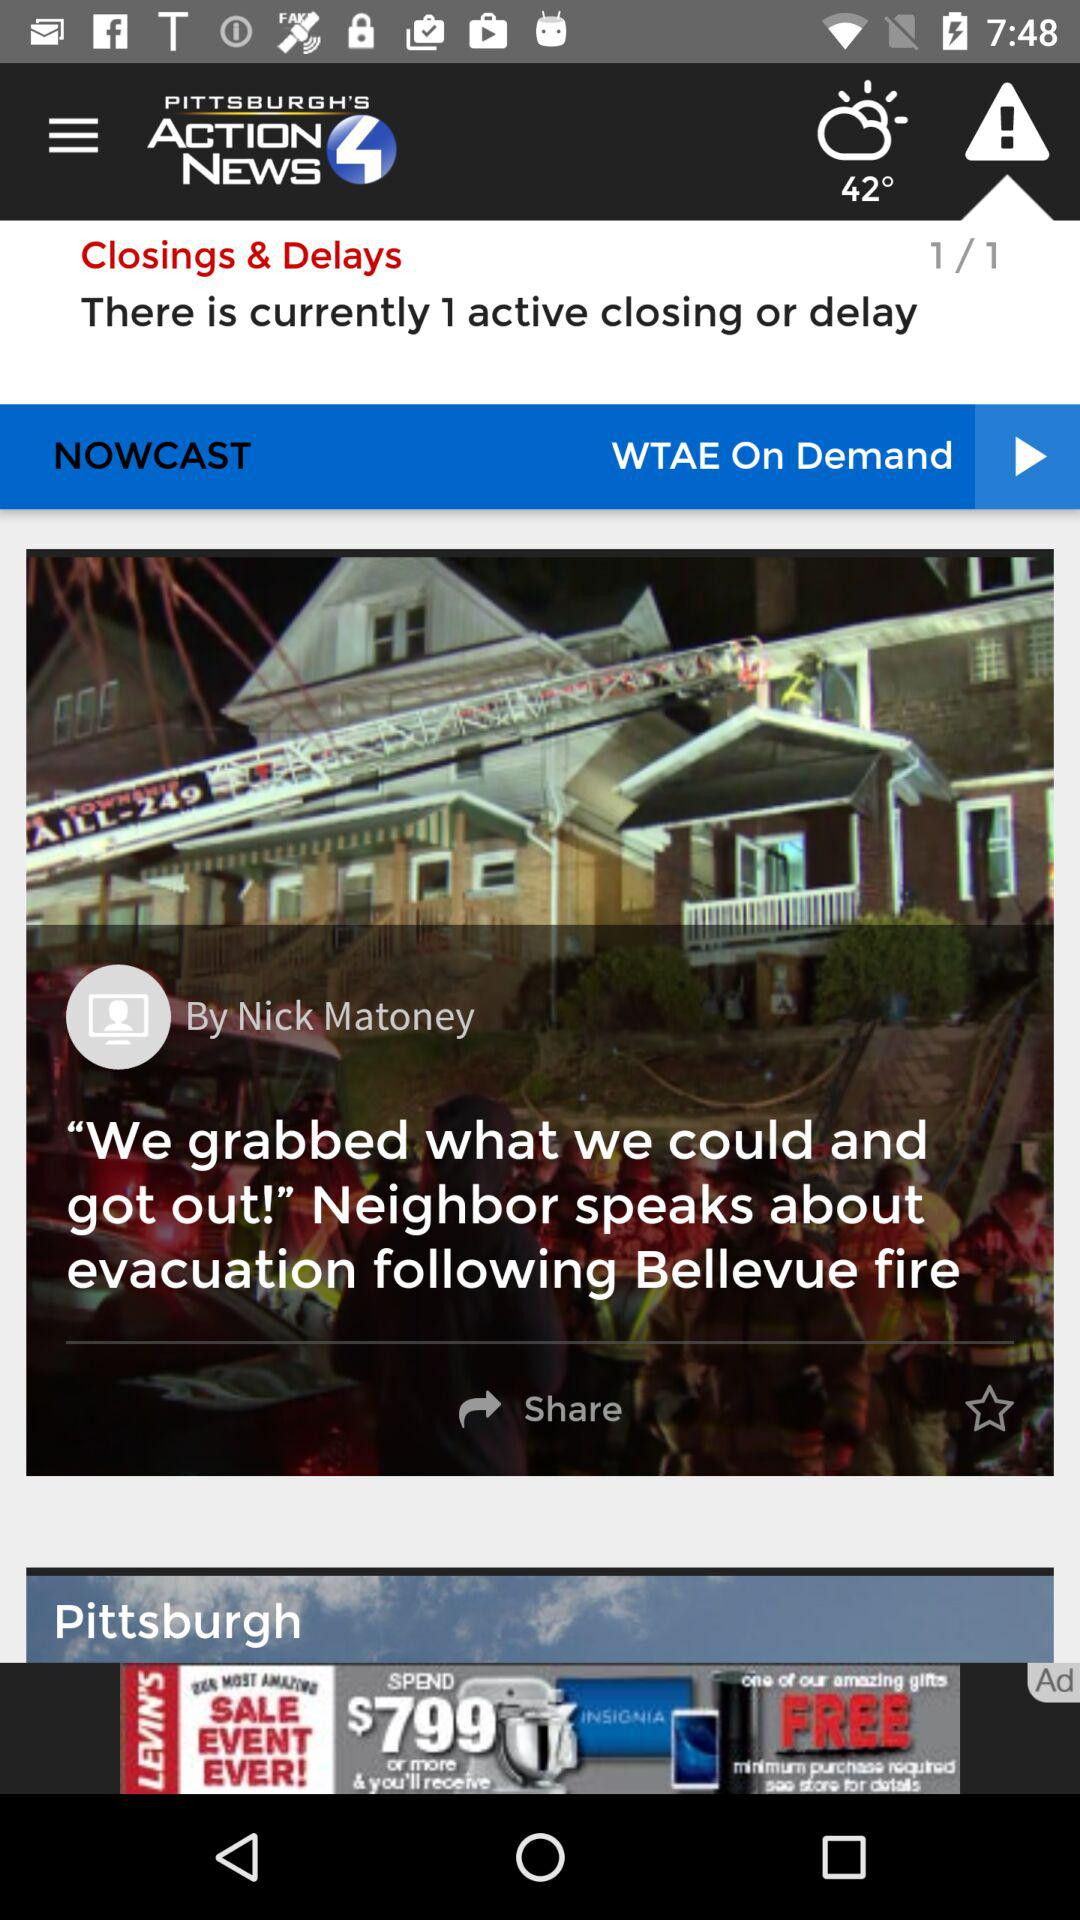What is the current temperature? The current temperature is 42°. 